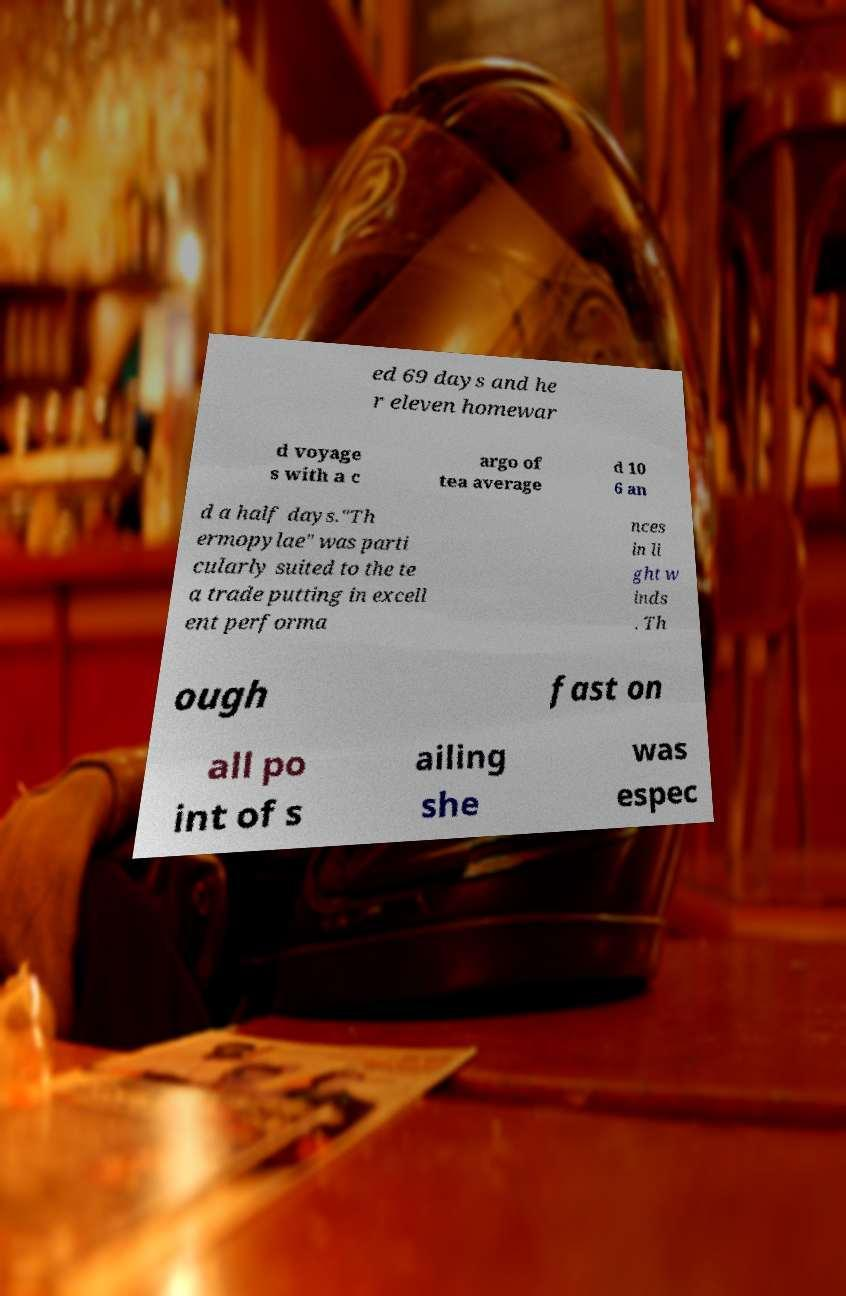Please read and relay the text visible in this image. What does it say? ed 69 days and he r eleven homewar d voyage s with a c argo of tea average d 10 6 an d a half days."Th ermopylae" was parti cularly suited to the te a trade putting in excell ent performa nces in li ght w inds . Th ough fast on all po int of s ailing she was espec 